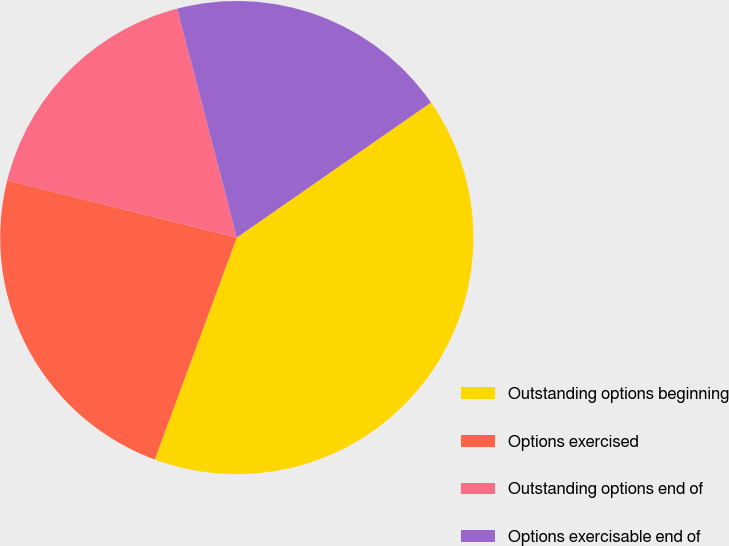Convert chart to OTSL. <chart><loc_0><loc_0><loc_500><loc_500><pie_chart><fcel>Outstanding options beginning<fcel>Options exercised<fcel>Outstanding options end of<fcel>Options exercisable end of<nl><fcel>40.31%<fcel>23.25%<fcel>17.06%<fcel>19.38%<nl></chart> 